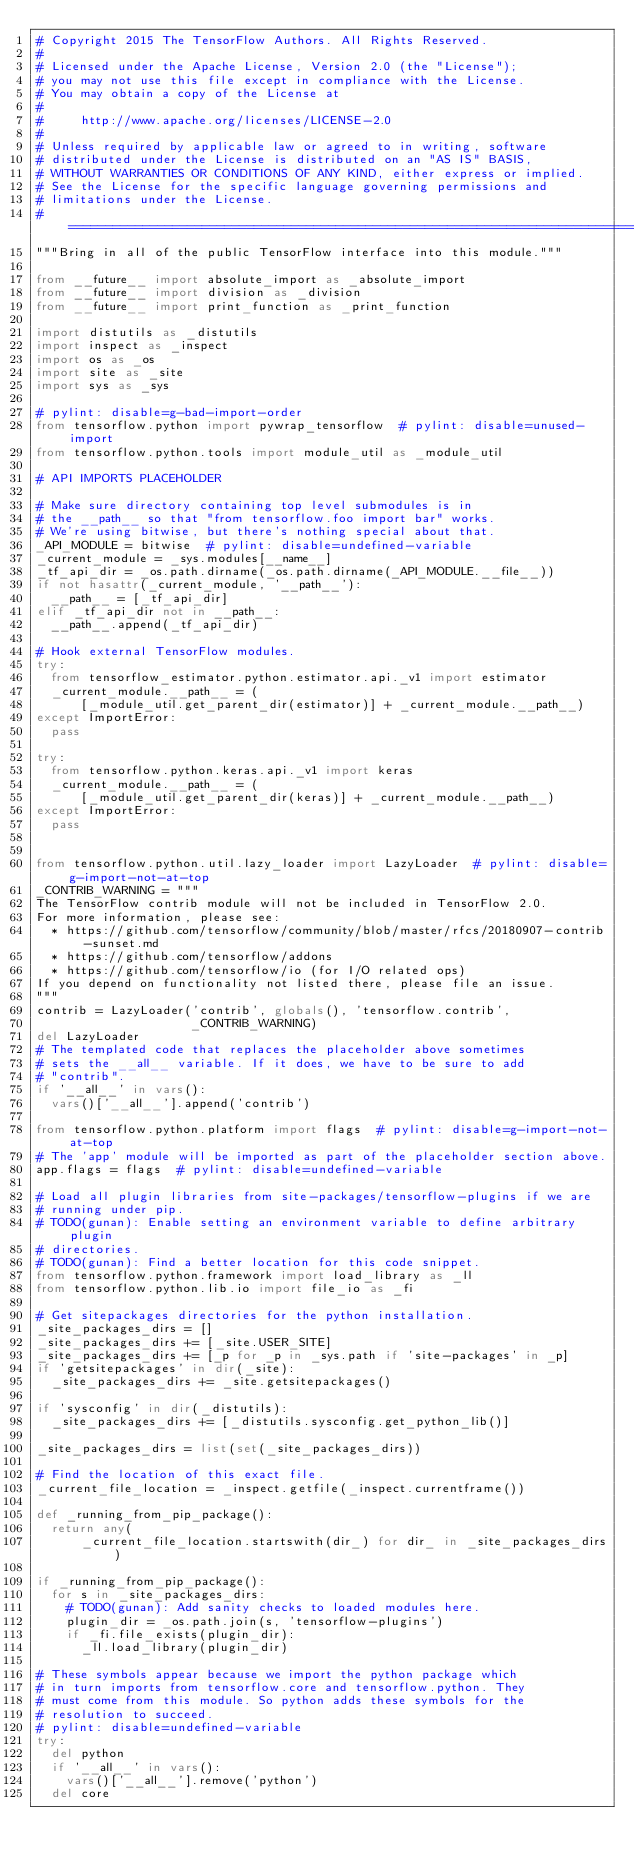<code> <loc_0><loc_0><loc_500><loc_500><_Python_># Copyright 2015 The TensorFlow Authors. All Rights Reserved.
#
# Licensed under the Apache License, Version 2.0 (the "License");
# you may not use this file except in compliance with the License.
# You may obtain a copy of the License at
#
#     http://www.apache.org/licenses/LICENSE-2.0
#
# Unless required by applicable law or agreed to in writing, software
# distributed under the License is distributed on an "AS IS" BASIS,
# WITHOUT WARRANTIES OR CONDITIONS OF ANY KIND, either express or implied.
# See the License for the specific language governing permissions and
# limitations under the License.
# ==============================================================================
"""Bring in all of the public TensorFlow interface into this module."""

from __future__ import absolute_import as _absolute_import
from __future__ import division as _division
from __future__ import print_function as _print_function

import distutils as _distutils
import inspect as _inspect
import os as _os
import site as _site
import sys as _sys

# pylint: disable=g-bad-import-order
from tensorflow.python import pywrap_tensorflow  # pylint: disable=unused-import
from tensorflow.python.tools import module_util as _module_util

# API IMPORTS PLACEHOLDER

# Make sure directory containing top level submodules is in
# the __path__ so that "from tensorflow.foo import bar" works.
# We're using bitwise, but there's nothing special about that.
_API_MODULE = bitwise  # pylint: disable=undefined-variable
_current_module = _sys.modules[__name__]
_tf_api_dir = _os.path.dirname(_os.path.dirname(_API_MODULE.__file__))
if not hasattr(_current_module, '__path__'):
  __path__ = [_tf_api_dir]
elif _tf_api_dir not in __path__:
  __path__.append(_tf_api_dir)

# Hook external TensorFlow modules.
try:
  from tensorflow_estimator.python.estimator.api._v1 import estimator
  _current_module.__path__ = (
      [_module_util.get_parent_dir(estimator)] + _current_module.__path__)
except ImportError:
  pass

try:
  from tensorflow.python.keras.api._v1 import keras
  _current_module.__path__ = (
      [_module_util.get_parent_dir(keras)] + _current_module.__path__)
except ImportError:
  pass


from tensorflow.python.util.lazy_loader import LazyLoader  # pylint: disable=g-import-not-at-top
_CONTRIB_WARNING = """
The TensorFlow contrib module will not be included in TensorFlow 2.0.
For more information, please see:
  * https://github.com/tensorflow/community/blob/master/rfcs/20180907-contrib-sunset.md
  * https://github.com/tensorflow/addons
  * https://github.com/tensorflow/io (for I/O related ops)
If you depend on functionality not listed there, please file an issue.
"""
contrib = LazyLoader('contrib', globals(), 'tensorflow.contrib',
                     _CONTRIB_WARNING)
del LazyLoader
# The templated code that replaces the placeholder above sometimes
# sets the __all__ variable. If it does, we have to be sure to add
# "contrib".
if '__all__' in vars():
  vars()['__all__'].append('contrib')

from tensorflow.python.platform import flags  # pylint: disable=g-import-not-at-top
# The 'app' module will be imported as part of the placeholder section above.
app.flags = flags  # pylint: disable=undefined-variable

# Load all plugin libraries from site-packages/tensorflow-plugins if we are
# running under pip.
# TODO(gunan): Enable setting an environment variable to define arbitrary plugin
# directories.
# TODO(gunan): Find a better location for this code snippet.
from tensorflow.python.framework import load_library as _ll
from tensorflow.python.lib.io import file_io as _fi

# Get sitepackages directories for the python installation.
_site_packages_dirs = []
_site_packages_dirs += [_site.USER_SITE]
_site_packages_dirs += [_p for _p in _sys.path if 'site-packages' in _p]
if 'getsitepackages' in dir(_site):
  _site_packages_dirs += _site.getsitepackages()

if 'sysconfig' in dir(_distutils):
  _site_packages_dirs += [_distutils.sysconfig.get_python_lib()]

_site_packages_dirs = list(set(_site_packages_dirs))

# Find the location of this exact file.
_current_file_location = _inspect.getfile(_inspect.currentframe())

def _running_from_pip_package():
  return any(
      _current_file_location.startswith(dir_) for dir_ in _site_packages_dirs)

if _running_from_pip_package():
  for s in _site_packages_dirs:
    # TODO(gunan): Add sanity checks to loaded modules here.
    plugin_dir = _os.path.join(s, 'tensorflow-plugins')
    if _fi.file_exists(plugin_dir):
      _ll.load_library(plugin_dir)

# These symbols appear because we import the python package which
# in turn imports from tensorflow.core and tensorflow.python. They
# must come from this module. So python adds these symbols for the
# resolution to succeed.
# pylint: disable=undefined-variable
try:
  del python
  if '__all__' in vars():
    vars()['__all__'].remove('python')
  del core</code> 